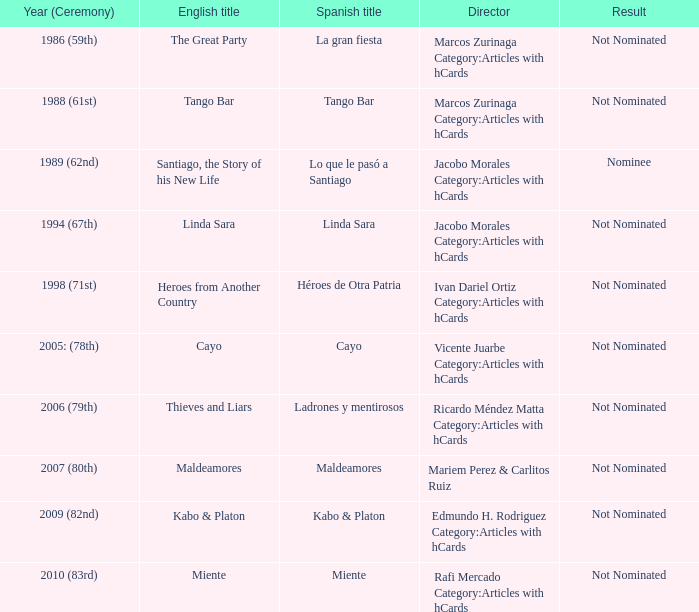What was the English title of Ladrones Y Mentirosos? Thieves and Liars. 